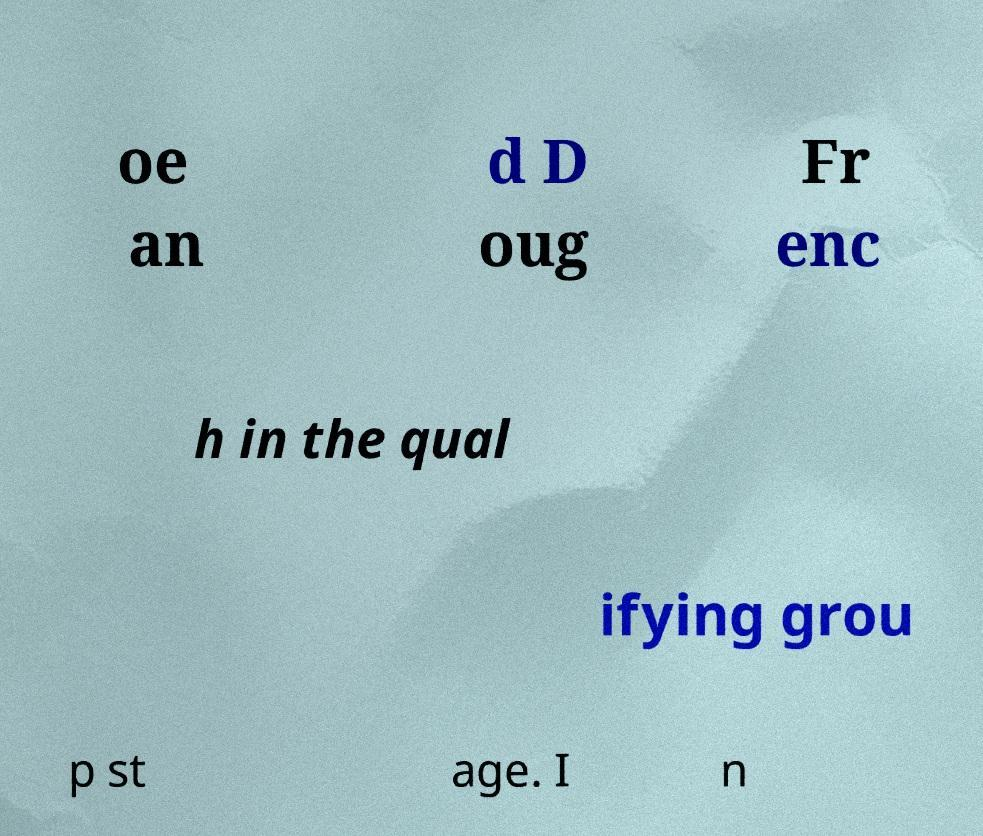What messages or text are displayed in this image? I need them in a readable, typed format. oe an d D oug Fr enc h in the qual ifying grou p st age. I n 